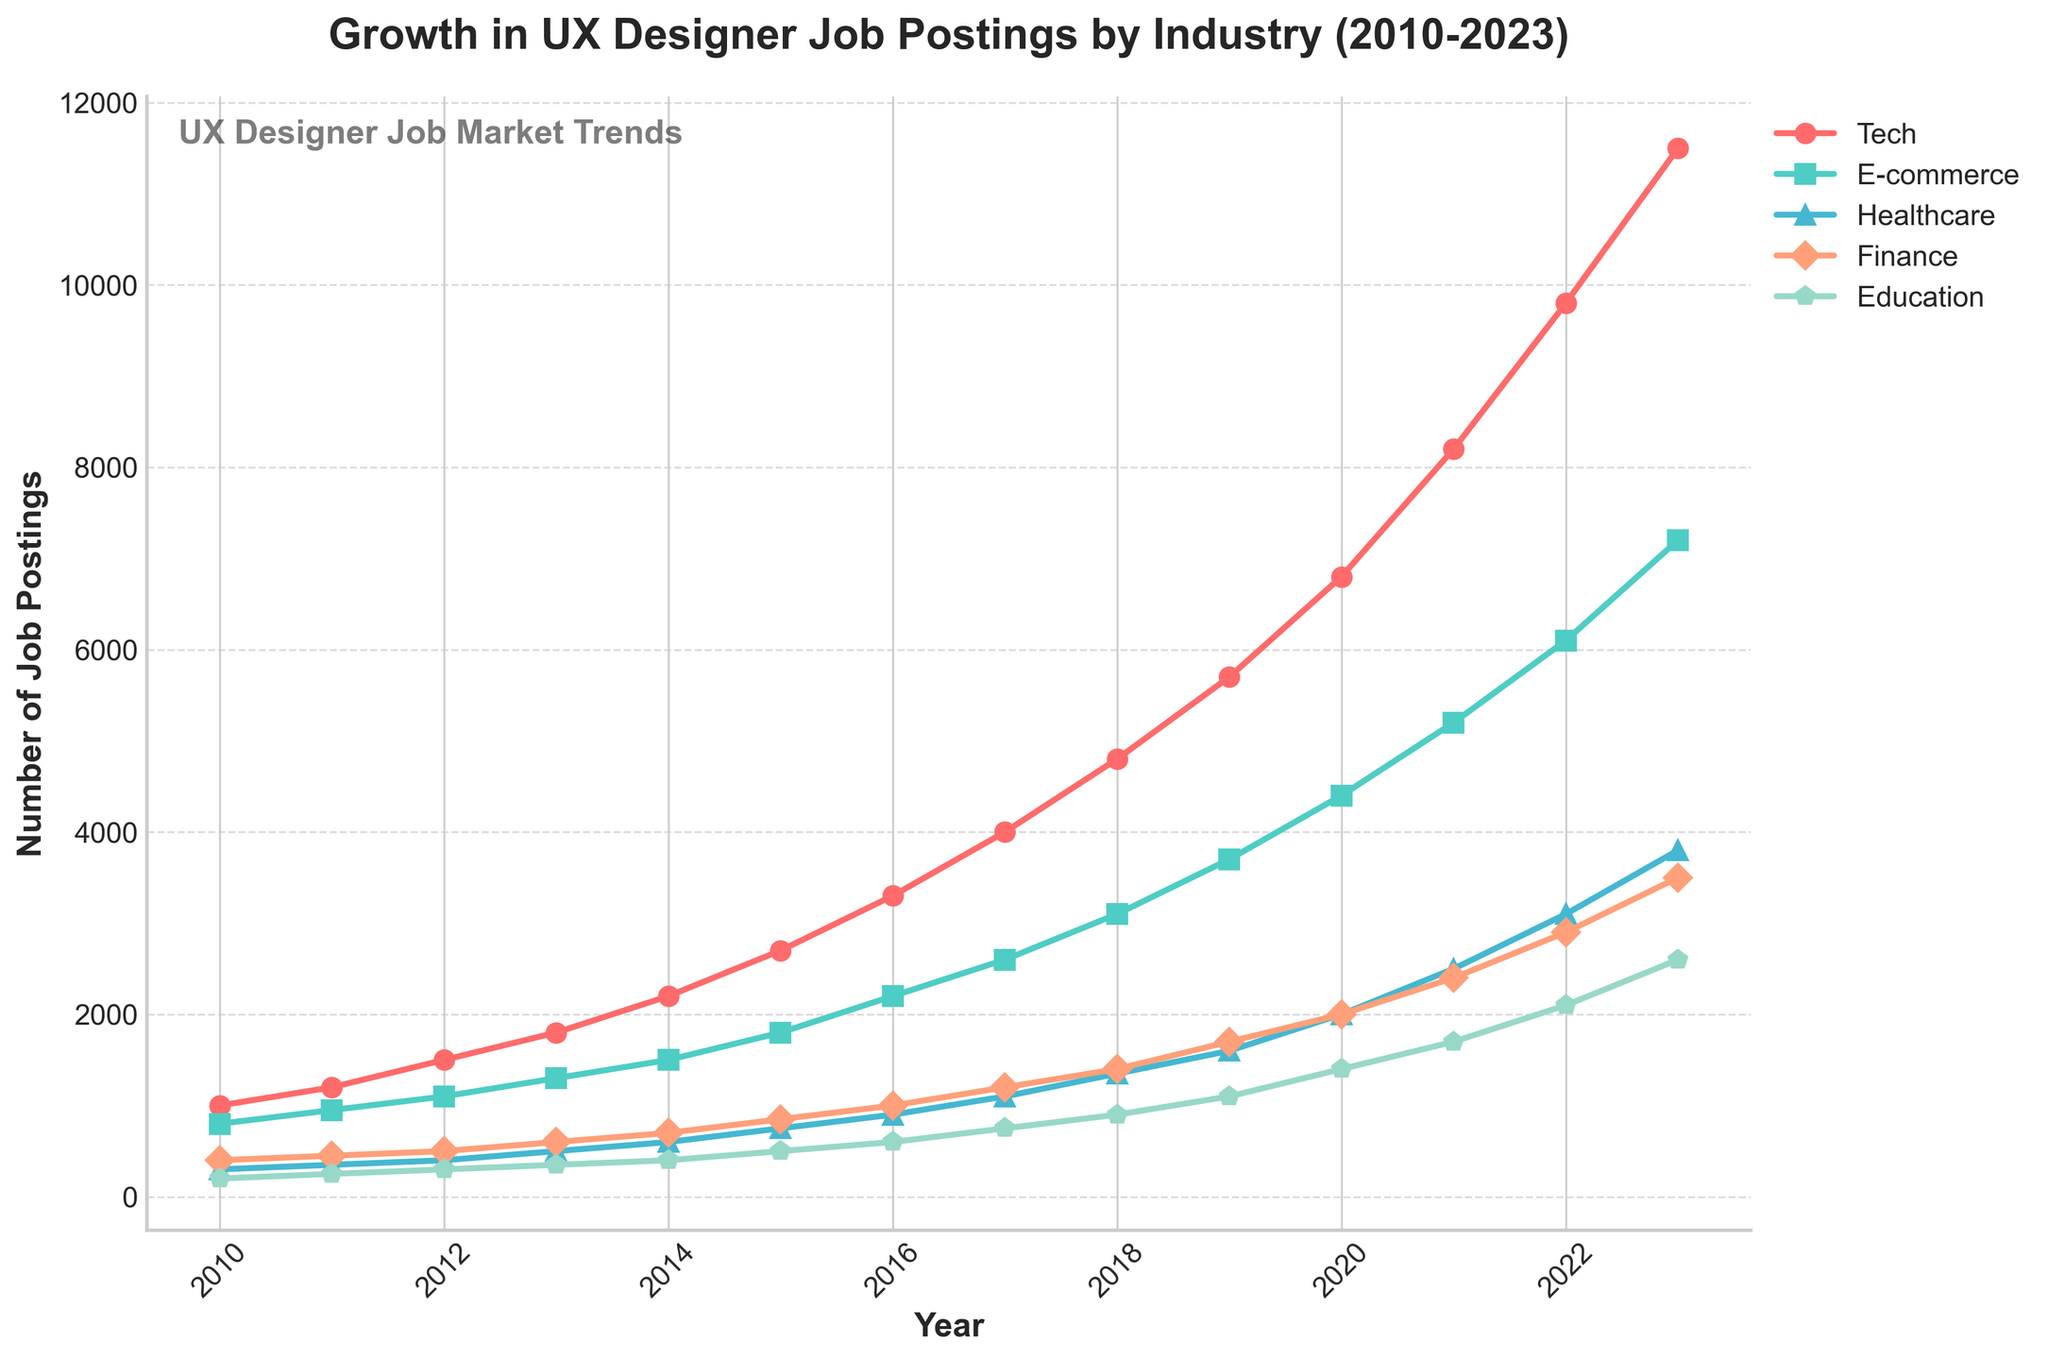Which industry has the highest number of job postings in 2023? By examining the figure, we can see that the 'Tech' industry curve is the highest at the end of the timeline, peaking in 2023.
Answer: Tech How many job postings were there in the Healthcare industry in 2015? The figure shows the 'Healthcare' industry curve intersecting the y-axis, and in 2015, it is at the 750 mark.
Answer: 750 Between which two consecutive years did the Tech industry see the largest increase in job postings? By comparing the vertical rises between consecutive years for the Tech industry curve, the largest jump appears to be between 2021 and 2022.
Answer: 2021 to 2022 What is the difference in job postings for the Finance industry between 2012 and 2018? The Finance curve in the figure is at 500 in 2012 and 1400 in 2018. The difference is 1400 - 500 = 900.
Answer: 900 Which industry had the slowest growth in job postings from 2010 to 2023? By observing the slopes of the curves, the Education industry shows the slowest growth, with the least steep incline over the years.
Answer: Education Compare the number of job postings in the Education and E-commerce industries in 2020. Which one had more job postings and by how much? In 2020, the E-commerce curve was at 4400 while the Education curve was at 1400. The difference is 4400 - 1400 = 3000, with E-commerce having more postings.
Answer: E-commerce by 3000 What trend do you observe in the job postings for the Tech industry from 2010 to 2023? The Tech industry shows a consistent upward trend, with job postings increasing significantly each year.
Answer: Consistent upward trend If you average the job postings for the E-commerce industry over the years provided, what is the average? Summing the job postings for E-commerce from 2010 to 2023: 800 + 950 + 1100 + 1300 + 1500 + 1800 + 2200 + 2600 + 3100 + 3700 + 4400 + 5200 + 6100 + 7200 = 46350. Dividing by 14 (number of years), the average is 46350 / 14 ≈ 3311.
Answer: 3311 What color represents the Healthcare industry line on the graph? The Healthcare industry line in the graph is represented in blue color.
Answer: Blue Which industry experienced the steepest growth between the years 2020 and 2021? Observing the graph, the Tech industry line shows the steepest incline between 2020 and 2021, indicating the highest growth in job postings during that period.
Answer: Tech How many more job postings were there in the Education industry in 2023 compared to 2010? The Education industry curve shows 2600 postings in 2023 and 200 in 2010. The difference is 2600 - 200 = 2400.
Answer: 2400 